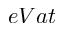<formula> <loc_0><loc_0><loc_500><loc_500>e V a t</formula> 